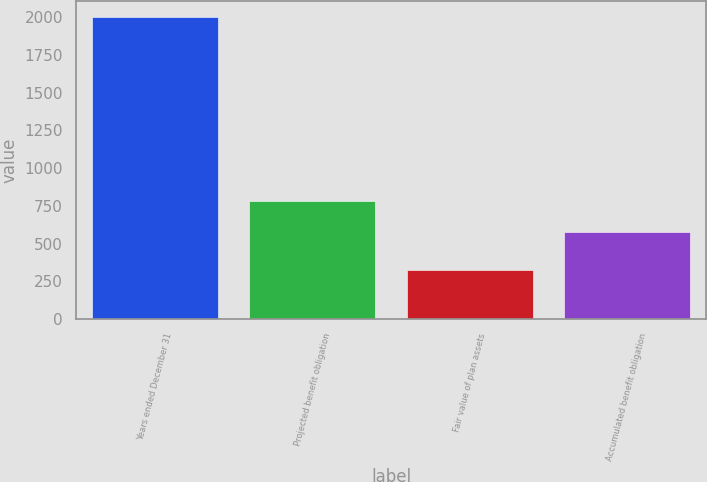Convert chart to OTSL. <chart><loc_0><loc_0><loc_500><loc_500><bar_chart><fcel>Years ended December 31<fcel>Projected benefit obligation<fcel>Fair value of plan assets<fcel>Accumulated benefit obligation<nl><fcel>2003<fcel>778.6<fcel>324.2<fcel>574.4<nl></chart> 